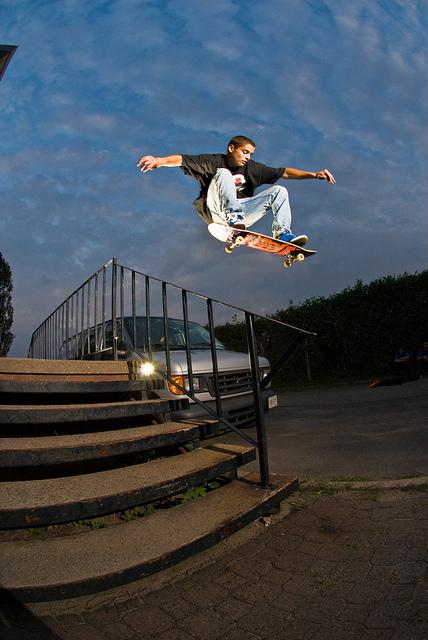The skateboarder would have to Ollie at least how high to clear the top of the railing? eight feet 